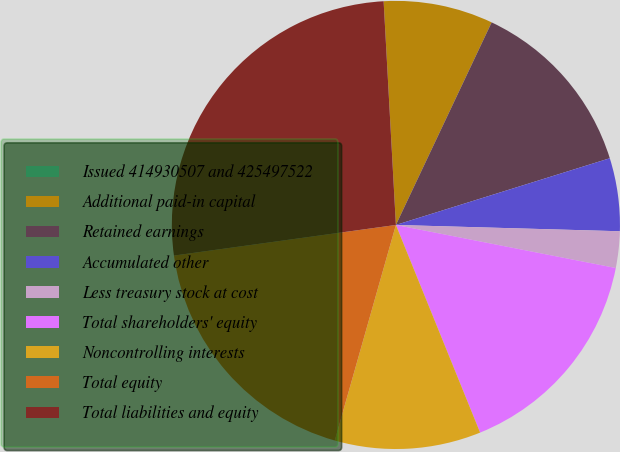Convert chart. <chart><loc_0><loc_0><loc_500><loc_500><pie_chart><fcel>Issued 414930507 and 425497522<fcel>Additional paid-in capital<fcel>Retained earnings<fcel>Accumulated other<fcel>Less treasury stock at cost<fcel>Total shareholders' equity<fcel>Noncontrolling interests<fcel>Total equity<fcel>Total liabilities and equity<nl><fcel>0.0%<fcel>7.9%<fcel>13.16%<fcel>5.26%<fcel>2.63%<fcel>15.79%<fcel>10.53%<fcel>18.42%<fcel>26.31%<nl></chart> 